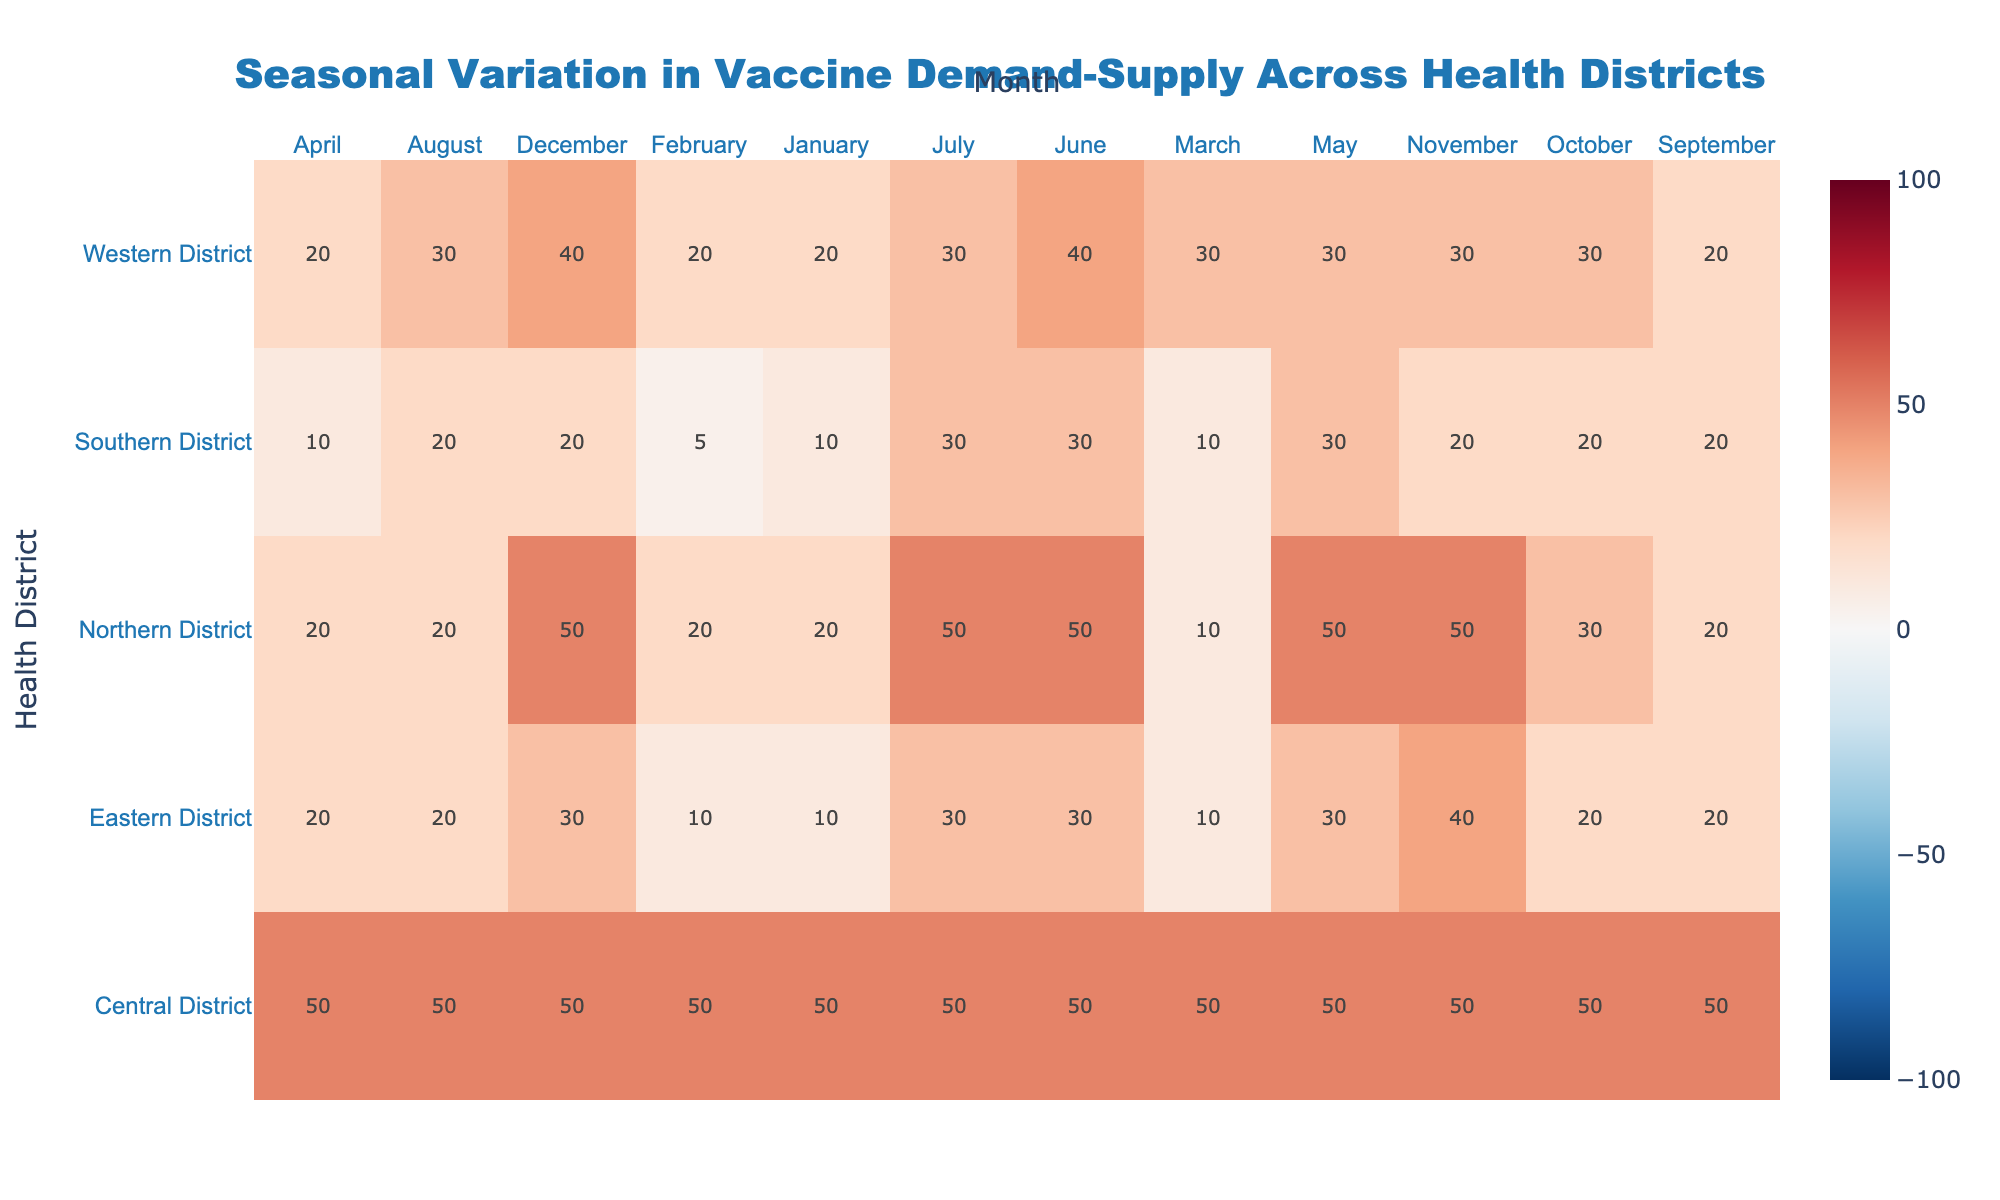What's the title of the heatmap? The title is usually placed at the top of the heatmap in the center. It serves as a brief summary of what the figure represents. In this case, the title can be gleaned by simply reading it directly from the figure.
Answer: "Seasonal Variation in Vaccine Demand-Supply Across Health Districts" Which health district shows the highest difference between demand and supply in May? To find the highest difference, scan the May column for each health district and identify the cell with the highest positive or negative value. Compare these values and select the highest absolute difference.
Answer: Western District What is the demand-supply difference in the Central District for March? Locate the cell corresponding to the Central District in the March column. The text inside the cell indicates the difference. In this case, it is the demand (800) minus the supply (750).
Answer: 50 Which month shows the lowest difference between demand and supply for the Southern District? Review the Southern District row and compare the difference values for each month. Identify the cell with the lowest (most negative) value. August has demand (260) and supply (240), so the difference is 20.
Answer: August How does the demand-supply difference in July compare between the Northern and Eastern Districts? Locate the July column and compare the values for the Northern (550-500) and Eastern (650-620) Districts. Calculate the difference for each and compare. Northern is 50; Eastern is: 30.
Answer: Northern has a higher difference Which health district has the most supply shortages in December? Identify the December column and compare the differences for each health district. Select the district with the most negative value, indicating the greatest shortage.
Answer: Western District What are the demand-supply differences for the Southern District from January to June? Look at the Southern District row and list the demand-supply differences for each month from January (300-290) to June (780-750).
Answer: 10, 5, 10, 10, 30, 30 In which month does the Central District have the smallest positive difference between demand and supply? Locate the Central District row and identify the smallest positive value across all columns. Compare each of the values visually shown in the heatmap.
Answer: August Are there any health districts that face a surplus in July? Check the July column to see if any health districts have a negative or zero difference (meaning supply meets or exceeds demand). Both Eastern (30) and Western (30) have lower supply issues, indicating overall surplus compared to other months.
Answer: Eastern, Western What color denotes the highest demand-supply difference and which district(s) does it appear in? Look at the colorbar and identify the color representing the highest demand-supply difference. Scan the heatmap for this color and mention the corresponding district(s).
Answer: Dark Red, Western District 